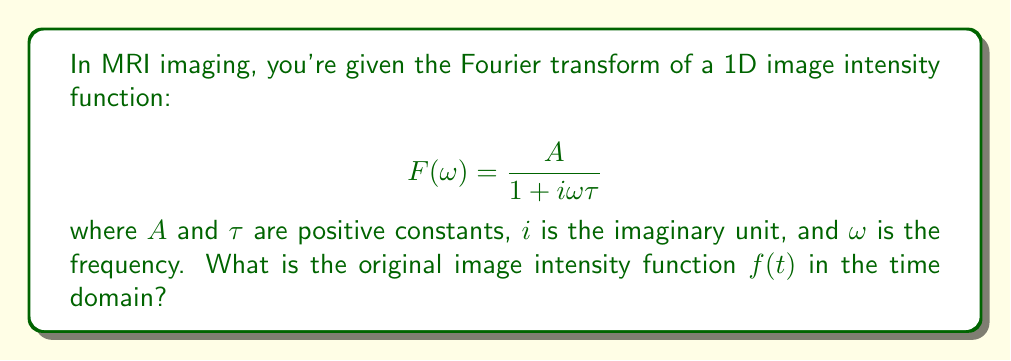Give your solution to this math problem. Let's approach this step-by-step:

1) The given function $F(\omega)$ is the Fourier transform of the original function $f(t)$ we're looking for.

2) This form of Fourier transform is recognizable as corresponding to an exponential decay function in the time domain.

3) The inverse Fourier transform of $\frac{1}{1 + i\omega\tau}$ is known to be:

   $$\frac{1}{\tau}e^{-t/\tau}$$  for $t \geq 0$

4) However, our function has an additional factor $A$. Due to the linearity property of Fourier transforms, this simply scales the time-domain function by $A$.

5) Therefore, the inverse Fourier transform of $\frac{A}{1 + i\omega\tau}$ is:

   $$f(t) = \frac{A}{\tau}e^{-t/\tau}$$  for $t \geq 0$

6) This function represents an exponential decay starting at $t=0$, with initial value $\frac{A}{\tau}$ and decay constant $\frac{1}{\tau}$.

7) In the context of MRI, this could represent the intensity of a signal decaying over time after an initial excitation.
Answer: $f(t) = \frac{A}{\tau}e^{-t/\tau}$ for $t \geq 0$ 